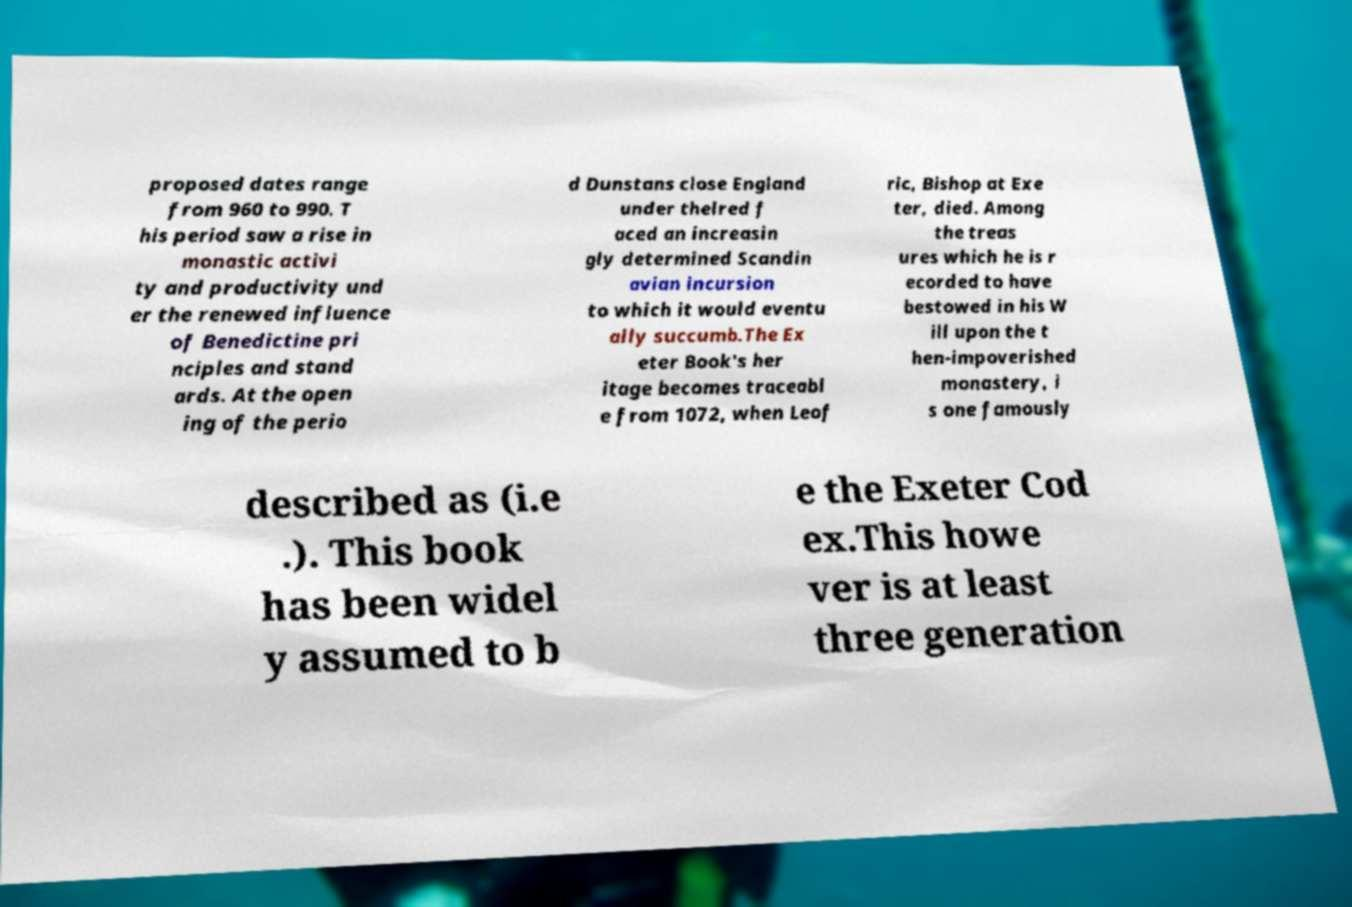Can you accurately transcribe the text from the provided image for me? proposed dates range from 960 to 990. T his period saw a rise in monastic activi ty and productivity und er the renewed influence of Benedictine pri nciples and stand ards. At the open ing of the perio d Dunstans close England under thelred f aced an increasin gly determined Scandin avian incursion to which it would eventu ally succumb.The Ex eter Book's her itage becomes traceabl e from 1072, when Leof ric, Bishop at Exe ter, died. Among the treas ures which he is r ecorded to have bestowed in his W ill upon the t hen-impoverished monastery, i s one famously described as (i.e .). This book has been widel y assumed to b e the Exeter Cod ex.This howe ver is at least three generation 